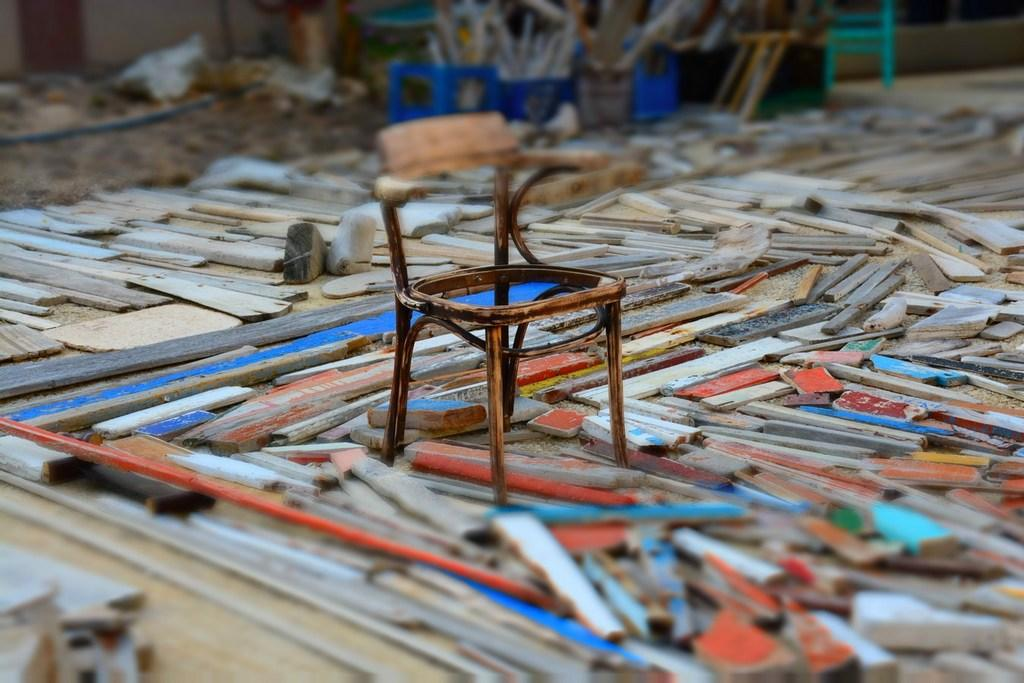What type of furniture is present in the image? There is a chair in the image. What material are the objects around the chair made of? The objects around the chair are made of wood. Can you describe the background of the image? The background of the image is blurry. Are there any other chairs visible in the image? Yes, there is another chair visible in the background. Can you see any yaks in the image? No, there are no yaks present in the image. What type of can is visible in the image? There is no can present in the image. 